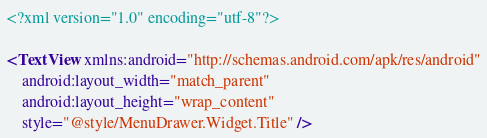<code> <loc_0><loc_0><loc_500><loc_500><_XML_><?xml version="1.0" encoding="utf-8"?>

<TextView xmlns:android="http://schemas.android.com/apk/res/android"
    android:layout_width="match_parent"
    android:layout_height="wrap_content"
    style="@style/MenuDrawer.Widget.Title" />
</code> 